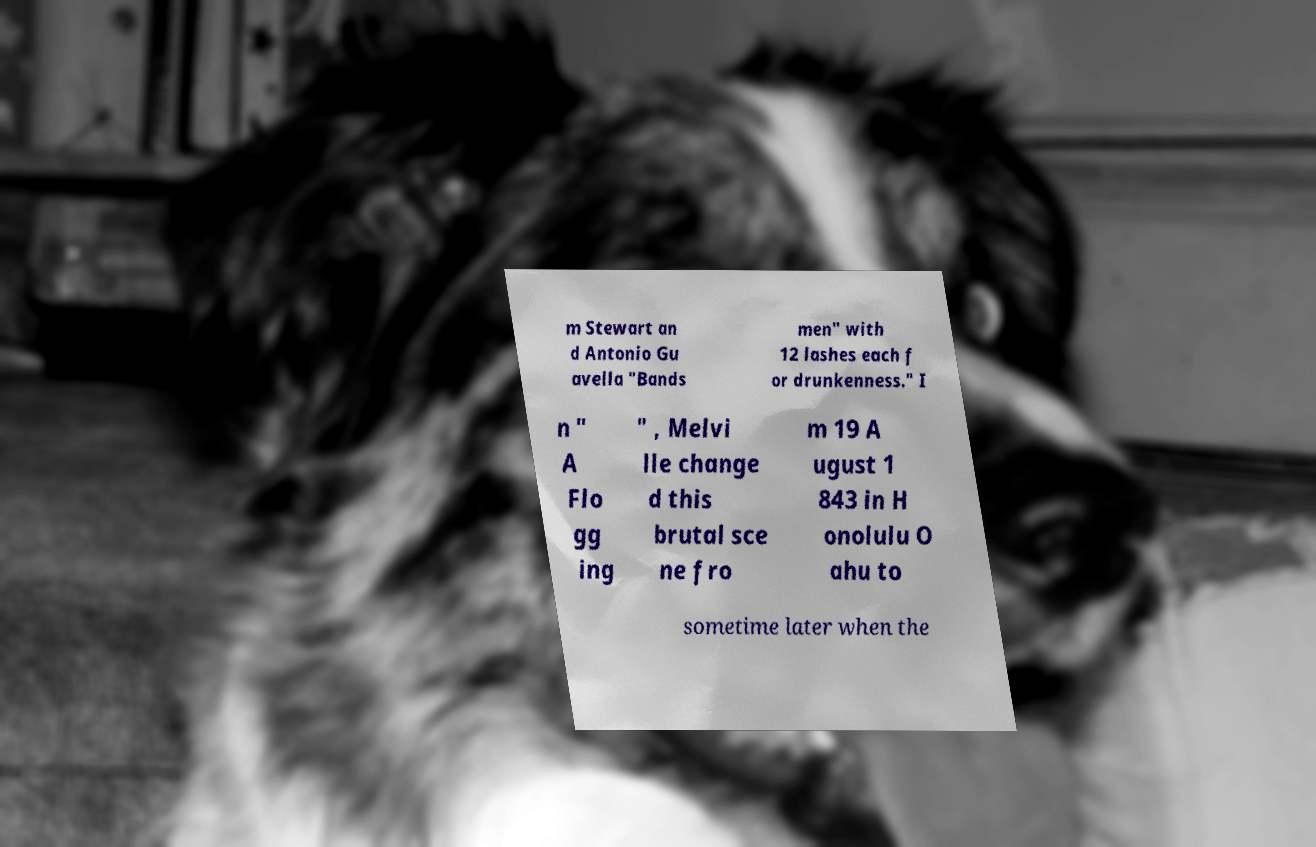There's text embedded in this image that I need extracted. Can you transcribe it verbatim? m Stewart an d Antonio Gu avella "Bands men" with 12 lashes each f or drunkenness." I n " A Flo gg ing " , Melvi lle change d this brutal sce ne fro m 19 A ugust 1 843 in H onolulu O ahu to sometime later when the 